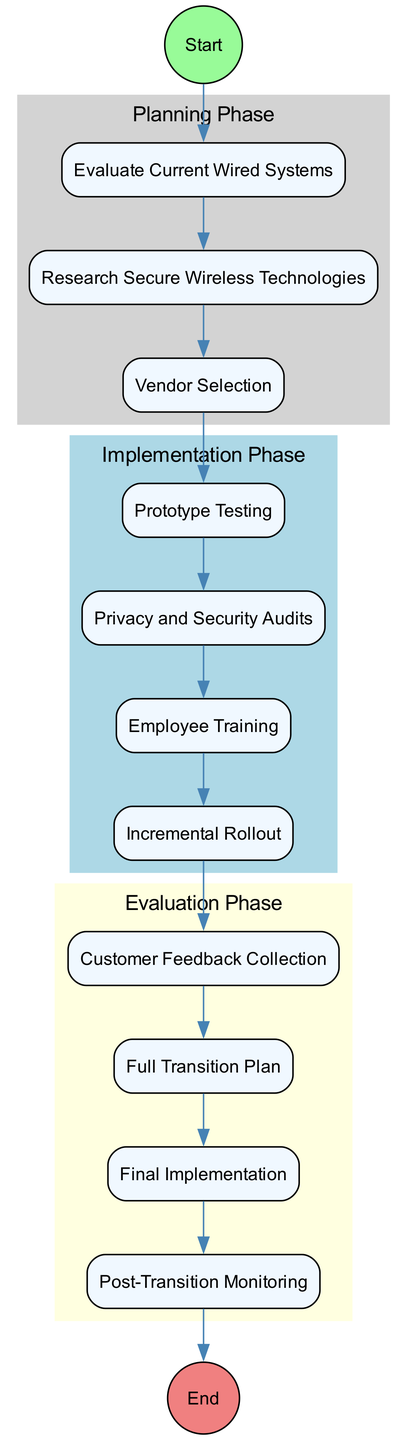What is the starting point of the transition process? The diagram indicates that the starting point of the transition process is labeled "Begin Transition Process." This is the first node in the flow, leading to the subsequent activities.
Answer: Begin Transition Process How many activities are in the diagram? The diagram includes a total of eleven activities. By counting each distinct activity node listed in the data provided, we reach this total.
Answer: Eleven Which activity follows "Vendor Selection"? According to the flow of activities, "Prototype Testing" directly follows "Vendor Selection." This can be seen as we move sequentially through the activities in the diagram.
Answer: Prototype Testing What is the final step in the transition process? The concluding activity in the diagram is "Transition Complete," which signifies the end of the entire transition process. This is marked as the last node following all preceding activities.
Answer: Transition Complete What phase does "Privacy and Security Audits" belong to? The activity "Privacy and Security Audits" falls within the Implementation Phase, as defined by the grouping of activities that focus on executing and evaluating new systems.
Answer: Implementation Phase What is the purpose of "Customer Feedback Collection"? The purpose of "Customer Feedback Collection" is to gather feedback from initial rollouts, which helps to understand customer satisfaction and identify any privacy or performance issues. This is specifically designed to inform further decisions in the transition process.
Answer: Gather feedback Which activity is related to employee skills for the new system? The activity connected to employee skills for the new system is "Employee Training," which focuses on training technical staff and security personnel on the installation and maintenance of the wireless systems.
Answer: Employee Training In which phase is "Final Implementation" categorized? The "Final Implementation" activity is categorized under the Evaluation Phase, as this represents the execution of the complete transition to wireless systems after preceding evaluations and audits.
Answer: Evaluation Phase What is the relationship between "Prototype Testing" and "Privacy and Security Audits"? The relationship between "Prototype Testing" and "Privacy and Security Audits" is sequential, where "Prototype Testing" occurs before "Privacy and Security Audits," indicating that testing is done prior to conducting the audits.
Answer: Sequential relationship 